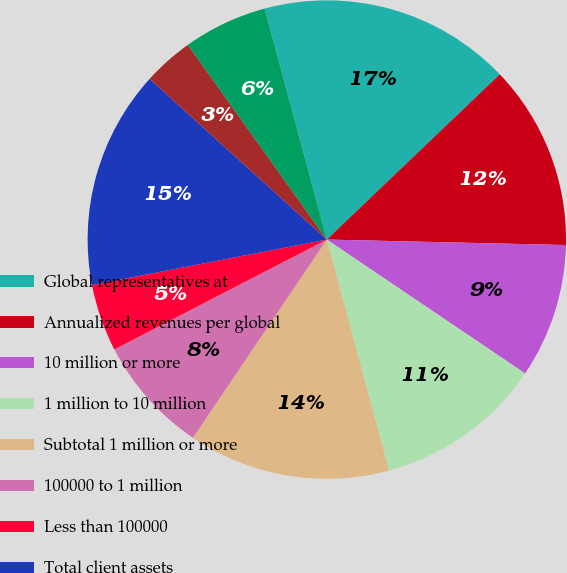Convert chart to OTSL. <chart><loc_0><loc_0><loc_500><loc_500><pie_chart><fcel>Global representatives at<fcel>Annualized revenues per global<fcel>10 million or more<fcel>1 million to 10 million<fcel>Subtotal 1 million or more<fcel>100000 to 1 million<fcel>Less than 100000<fcel>Total client assets<fcel>Fee-based client assets as a<fcel>Client assets per global<nl><fcel>17.05%<fcel>12.5%<fcel>9.09%<fcel>11.36%<fcel>13.64%<fcel>7.95%<fcel>4.55%<fcel>14.77%<fcel>3.41%<fcel>5.68%<nl></chart> 